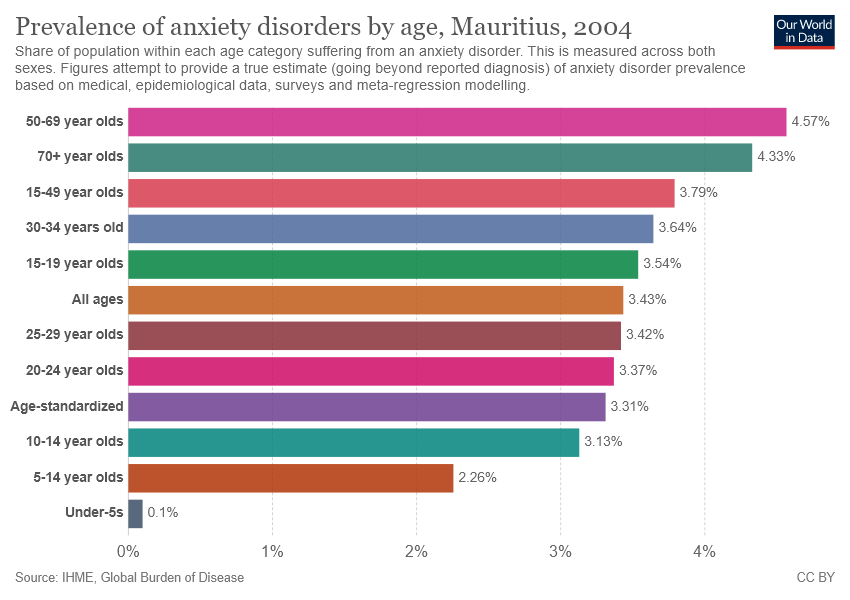Identify some key points in this picture. The age group represented by the dark green color bar is 70 years and older. The percentage difference between the age groups having the highest and lowest prevalence of anxiety disorders is 0.0447. 